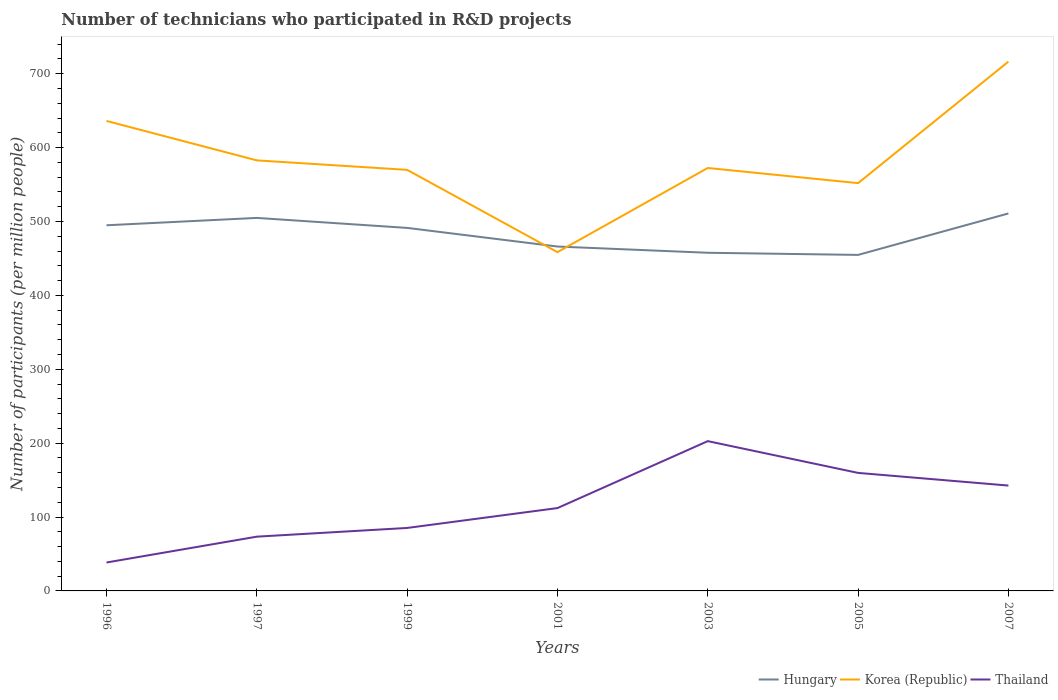Does the line corresponding to Thailand intersect with the line corresponding to Hungary?
Make the answer very short. No. Is the number of lines equal to the number of legend labels?
Offer a very short reply. Yes. Across all years, what is the maximum number of technicians who participated in R&D projects in Korea (Republic)?
Your response must be concise. 458.44. What is the total number of technicians who participated in R&D projects in Korea (Republic) in the graph?
Offer a very short reply. 17.98. What is the difference between the highest and the second highest number of technicians who participated in R&D projects in Thailand?
Your answer should be compact. 164.25. Does the graph contain any zero values?
Give a very brief answer. No. Where does the legend appear in the graph?
Provide a short and direct response. Bottom right. How many legend labels are there?
Ensure brevity in your answer.  3. How are the legend labels stacked?
Provide a succinct answer. Horizontal. What is the title of the graph?
Ensure brevity in your answer.  Number of technicians who participated in R&D projects. Does "Turkmenistan" appear as one of the legend labels in the graph?
Keep it short and to the point. No. What is the label or title of the Y-axis?
Make the answer very short. Number of participants (per million people). What is the Number of participants (per million people) of Hungary in 1996?
Give a very brief answer. 494.83. What is the Number of participants (per million people) of Korea (Republic) in 1996?
Provide a short and direct response. 636.02. What is the Number of participants (per million people) in Thailand in 1996?
Keep it short and to the point. 38.46. What is the Number of participants (per million people) in Hungary in 1997?
Your answer should be compact. 504.79. What is the Number of participants (per million people) of Korea (Republic) in 1997?
Provide a succinct answer. 582.66. What is the Number of participants (per million people) in Thailand in 1997?
Give a very brief answer. 73.43. What is the Number of participants (per million people) of Hungary in 1999?
Your answer should be very brief. 491.27. What is the Number of participants (per million people) of Korea (Republic) in 1999?
Your answer should be compact. 569.83. What is the Number of participants (per million people) of Thailand in 1999?
Make the answer very short. 85.21. What is the Number of participants (per million people) of Hungary in 2001?
Ensure brevity in your answer.  466.07. What is the Number of participants (per million people) of Korea (Republic) in 2001?
Ensure brevity in your answer.  458.44. What is the Number of participants (per million people) of Thailand in 2001?
Keep it short and to the point. 112.12. What is the Number of participants (per million people) of Hungary in 2003?
Your answer should be compact. 457.63. What is the Number of participants (per million people) of Korea (Republic) in 2003?
Your response must be concise. 572.37. What is the Number of participants (per million people) in Thailand in 2003?
Ensure brevity in your answer.  202.71. What is the Number of participants (per million people) in Hungary in 2005?
Ensure brevity in your answer.  454.74. What is the Number of participants (per million people) of Korea (Republic) in 2005?
Your response must be concise. 551.85. What is the Number of participants (per million people) in Thailand in 2005?
Ensure brevity in your answer.  159.72. What is the Number of participants (per million people) in Hungary in 2007?
Your response must be concise. 510.82. What is the Number of participants (per million people) in Korea (Republic) in 2007?
Keep it short and to the point. 716.3. What is the Number of participants (per million people) in Thailand in 2007?
Give a very brief answer. 142.58. Across all years, what is the maximum Number of participants (per million people) of Hungary?
Your answer should be compact. 510.82. Across all years, what is the maximum Number of participants (per million people) of Korea (Republic)?
Make the answer very short. 716.3. Across all years, what is the maximum Number of participants (per million people) of Thailand?
Ensure brevity in your answer.  202.71. Across all years, what is the minimum Number of participants (per million people) of Hungary?
Give a very brief answer. 454.74. Across all years, what is the minimum Number of participants (per million people) of Korea (Republic)?
Offer a terse response. 458.44. Across all years, what is the minimum Number of participants (per million people) of Thailand?
Offer a terse response. 38.46. What is the total Number of participants (per million people) in Hungary in the graph?
Offer a terse response. 3380.14. What is the total Number of participants (per million people) in Korea (Republic) in the graph?
Offer a very short reply. 4087.47. What is the total Number of participants (per million people) in Thailand in the graph?
Keep it short and to the point. 814.24. What is the difference between the Number of participants (per million people) of Hungary in 1996 and that in 1997?
Make the answer very short. -9.96. What is the difference between the Number of participants (per million people) of Korea (Republic) in 1996 and that in 1997?
Offer a very short reply. 53.36. What is the difference between the Number of participants (per million people) in Thailand in 1996 and that in 1997?
Offer a terse response. -34.97. What is the difference between the Number of participants (per million people) of Hungary in 1996 and that in 1999?
Provide a short and direct response. 3.56. What is the difference between the Number of participants (per million people) in Korea (Republic) in 1996 and that in 1999?
Your answer should be very brief. 66.19. What is the difference between the Number of participants (per million people) of Thailand in 1996 and that in 1999?
Offer a terse response. -46.75. What is the difference between the Number of participants (per million people) of Hungary in 1996 and that in 2001?
Your answer should be very brief. 28.76. What is the difference between the Number of participants (per million people) in Korea (Republic) in 1996 and that in 2001?
Provide a short and direct response. 177.58. What is the difference between the Number of participants (per million people) in Thailand in 1996 and that in 2001?
Offer a terse response. -73.66. What is the difference between the Number of participants (per million people) of Hungary in 1996 and that in 2003?
Provide a short and direct response. 37.2. What is the difference between the Number of participants (per million people) in Korea (Republic) in 1996 and that in 2003?
Your answer should be very brief. 63.65. What is the difference between the Number of participants (per million people) in Thailand in 1996 and that in 2003?
Offer a terse response. -164.25. What is the difference between the Number of participants (per million people) in Hungary in 1996 and that in 2005?
Your answer should be compact. 40.09. What is the difference between the Number of participants (per million people) in Korea (Republic) in 1996 and that in 2005?
Keep it short and to the point. 84.16. What is the difference between the Number of participants (per million people) in Thailand in 1996 and that in 2005?
Offer a very short reply. -121.26. What is the difference between the Number of participants (per million people) of Hungary in 1996 and that in 2007?
Your response must be concise. -15.99. What is the difference between the Number of participants (per million people) in Korea (Republic) in 1996 and that in 2007?
Ensure brevity in your answer.  -80.28. What is the difference between the Number of participants (per million people) of Thailand in 1996 and that in 2007?
Provide a short and direct response. -104.12. What is the difference between the Number of participants (per million people) of Hungary in 1997 and that in 1999?
Your response must be concise. 13.52. What is the difference between the Number of participants (per million people) in Korea (Republic) in 1997 and that in 1999?
Your response must be concise. 12.83. What is the difference between the Number of participants (per million people) in Thailand in 1997 and that in 1999?
Your answer should be compact. -11.78. What is the difference between the Number of participants (per million people) of Hungary in 1997 and that in 2001?
Keep it short and to the point. 38.72. What is the difference between the Number of participants (per million people) of Korea (Republic) in 1997 and that in 2001?
Provide a succinct answer. 124.22. What is the difference between the Number of participants (per million people) of Thailand in 1997 and that in 2001?
Ensure brevity in your answer.  -38.69. What is the difference between the Number of participants (per million people) in Hungary in 1997 and that in 2003?
Your answer should be compact. 47.16. What is the difference between the Number of participants (per million people) of Korea (Republic) in 1997 and that in 2003?
Your response must be concise. 10.29. What is the difference between the Number of participants (per million people) in Thailand in 1997 and that in 2003?
Give a very brief answer. -129.28. What is the difference between the Number of participants (per million people) in Hungary in 1997 and that in 2005?
Make the answer very short. 50.05. What is the difference between the Number of participants (per million people) in Korea (Republic) in 1997 and that in 2005?
Ensure brevity in your answer.  30.8. What is the difference between the Number of participants (per million people) in Thailand in 1997 and that in 2005?
Provide a short and direct response. -86.29. What is the difference between the Number of participants (per million people) in Hungary in 1997 and that in 2007?
Your answer should be compact. -6.03. What is the difference between the Number of participants (per million people) in Korea (Republic) in 1997 and that in 2007?
Your response must be concise. -133.64. What is the difference between the Number of participants (per million people) in Thailand in 1997 and that in 2007?
Provide a succinct answer. -69.15. What is the difference between the Number of participants (per million people) in Hungary in 1999 and that in 2001?
Provide a succinct answer. 25.2. What is the difference between the Number of participants (per million people) of Korea (Republic) in 1999 and that in 2001?
Offer a terse response. 111.39. What is the difference between the Number of participants (per million people) of Thailand in 1999 and that in 2001?
Your response must be concise. -26.91. What is the difference between the Number of participants (per million people) in Hungary in 1999 and that in 2003?
Your response must be concise. 33.64. What is the difference between the Number of participants (per million people) in Korea (Republic) in 1999 and that in 2003?
Provide a succinct answer. -2.54. What is the difference between the Number of participants (per million people) of Thailand in 1999 and that in 2003?
Offer a very short reply. -117.5. What is the difference between the Number of participants (per million people) in Hungary in 1999 and that in 2005?
Offer a terse response. 36.53. What is the difference between the Number of participants (per million people) of Korea (Republic) in 1999 and that in 2005?
Your answer should be very brief. 17.98. What is the difference between the Number of participants (per million people) in Thailand in 1999 and that in 2005?
Give a very brief answer. -74.51. What is the difference between the Number of participants (per million people) in Hungary in 1999 and that in 2007?
Your answer should be very brief. -19.56. What is the difference between the Number of participants (per million people) of Korea (Republic) in 1999 and that in 2007?
Make the answer very short. -146.47. What is the difference between the Number of participants (per million people) of Thailand in 1999 and that in 2007?
Provide a succinct answer. -57.37. What is the difference between the Number of participants (per million people) in Hungary in 2001 and that in 2003?
Offer a terse response. 8.44. What is the difference between the Number of participants (per million people) in Korea (Republic) in 2001 and that in 2003?
Your response must be concise. -113.93. What is the difference between the Number of participants (per million people) of Thailand in 2001 and that in 2003?
Ensure brevity in your answer.  -90.59. What is the difference between the Number of participants (per million people) of Hungary in 2001 and that in 2005?
Ensure brevity in your answer.  11.33. What is the difference between the Number of participants (per million people) of Korea (Republic) in 2001 and that in 2005?
Give a very brief answer. -93.41. What is the difference between the Number of participants (per million people) in Thailand in 2001 and that in 2005?
Your answer should be compact. -47.6. What is the difference between the Number of participants (per million people) in Hungary in 2001 and that in 2007?
Your answer should be very brief. -44.76. What is the difference between the Number of participants (per million people) in Korea (Republic) in 2001 and that in 2007?
Make the answer very short. -257.86. What is the difference between the Number of participants (per million people) in Thailand in 2001 and that in 2007?
Make the answer very short. -30.47. What is the difference between the Number of participants (per million people) of Hungary in 2003 and that in 2005?
Make the answer very short. 2.89. What is the difference between the Number of participants (per million people) of Korea (Republic) in 2003 and that in 2005?
Offer a very short reply. 20.51. What is the difference between the Number of participants (per million people) in Thailand in 2003 and that in 2005?
Provide a short and direct response. 42.99. What is the difference between the Number of participants (per million people) in Hungary in 2003 and that in 2007?
Provide a succinct answer. -53.2. What is the difference between the Number of participants (per million people) of Korea (Republic) in 2003 and that in 2007?
Give a very brief answer. -143.93. What is the difference between the Number of participants (per million people) in Thailand in 2003 and that in 2007?
Your answer should be very brief. 60.12. What is the difference between the Number of participants (per million people) of Hungary in 2005 and that in 2007?
Provide a short and direct response. -56.09. What is the difference between the Number of participants (per million people) in Korea (Republic) in 2005 and that in 2007?
Give a very brief answer. -164.45. What is the difference between the Number of participants (per million people) in Thailand in 2005 and that in 2007?
Ensure brevity in your answer.  17.14. What is the difference between the Number of participants (per million people) of Hungary in 1996 and the Number of participants (per million people) of Korea (Republic) in 1997?
Offer a very short reply. -87.83. What is the difference between the Number of participants (per million people) in Hungary in 1996 and the Number of participants (per million people) in Thailand in 1997?
Your answer should be very brief. 421.4. What is the difference between the Number of participants (per million people) in Korea (Republic) in 1996 and the Number of participants (per million people) in Thailand in 1997?
Your response must be concise. 562.58. What is the difference between the Number of participants (per million people) of Hungary in 1996 and the Number of participants (per million people) of Korea (Republic) in 1999?
Ensure brevity in your answer.  -75. What is the difference between the Number of participants (per million people) in Hungary in 1996 and the Number of participants (per million people) in Thailand in 1999?
Make the answer very short. 409.62. What is the difference between the Number of participants (per million people) of Korea (Republic) in 1996 and the Number of participants (per million people) of Thailand in 1999?
Ensure brevity in your answer.  550.8. What is the difference between the Number of participants (per million people) of Hungary in 1996 and the Number of participants (per million people) of Korea (Republic) in 2001?
Keep it short and to the point. 36.39. What is the difference between the Number of participants (per million people) of Hungary in 1996 and the Number of participants (per million people) of Thailand in 2001?
Your answer should be compact. 382.71. What is the difference between the Number of participants (per million people) in Korea (Republic) in 1996 and the Number of participants (per million people) in Thailand in 2001?
Your response must be concise. 523.9. What is the difference between the Number of participants (per million people) of Hungary in 1996 and the Number of participants (per million people) of Korea (Republic) in 2003?
Your answer should be compact. -77.54. What is the difference between the Number of participants (per million people) in Hungary in 1996 and the Number of participants (per million people) in Thailand in 2003?
Your answer should be very brief. 292.12. What is the difference between the Number of participants (per million people) of Korea (Republic) in 1996 and the Number of participants (per million people) of Thailand in 2003?
Your answer should be very brief. 433.31. What is the difference between the Number of participants (per million people) of Hungary in 1996 and the Number of participants (per million people) of Korea (Republic) in 2005?
Your response must be concise. -57.03. What is the difference between the Number of participants (per million people) of Hungary in 1996 and the Number of participants (per million people) of Thailand in 2005?
Make the answer very short. 335.11. What is the difference between the Number of participants (per million people) in Korea (Republic) in 1996 and the Number of participants (per million people) in Thailand in 2005?
Your answer should be compact. 476.29. What is the difference between the Number of participants (per million people) in Hungary in 1996 and the Number of participants (per million people) in Korea (Republic) in 2007?
Offer a very short reply. -221.47. What is the difference between the Number of participants (per million people) in Hungary in 1996 and the Number of participants (per million people) in Thailand in 2007?
Offer a terse response. 352.24. What is the difference between the Number of participants (per million people) of Korea (Republic) in 1996 and the Number of participants (per million people) of Thailand in 2007?
Your answer should be compact. 493.43. What is the difference between the Number of participants (per million people) in Hungary in 1997 and the Number of participants (per million people) in Korea (Republic) in 1999?
Offer a terse response. -65.04. What is the difference between the Number of participants (per million people) of Hungary in 1997 and the Number of participants (per million people) of Thailand in 1999?
Offer a very short reply. 419.58. What is the difference between the Number of participants (per million people) in Korea (Republic) in 1997 and the Number of participants (per million people) in Thailand in 1999?
Give a very brief answer. 497.44. What is the difference between the Number of participants (per million people) of Hungary in 1997 and the Number of participants (per million people) of Korea (Republic) in 2001?
Ensure brevity in your answer.  46.35. What is the difference between the Number of participants (per million people) of Hungary in 1997 and the Number of participants (per million people) of Thailand in 2001?
Make the answer very short. 392.67. What is the difference between the Number of participants (per million people) in Korea (Republic) in 1997 and the Number of participants (per million people) in Thailand in 2001?
Your response must be concise. 470.54. What is the difference between the Number of participants (per million people) in Hungary in 1997 and the Number of participants (per million people) in Korea (Republic) in 2003?
Your response must be concise. -67.58. What is the difference between the Number of participants (per million people) of Hungary in 1997 and the Number of participants (per million people) of Thailand in 2003?
Provide a succinct answer. 302.08. What is the difference between the Number of participants (per million people) of Korea (Republic) in 1997 and the Number of participants (per million people) of Thailand in 2003?
Provide a short and direct response. 379.95. What is the difference between the Number of participants (per million people) in Hungary in 1997 and the Number of participants (per million people) in Korea (Republic) in 2005?
Keep it short and to the point. -47.06. What is the difference between the Number of participants (per million people) of Hungary in 1997 and the Number of participants (per million people) of Thailand in 2005?
Provide a succinct answer. 345.07. What is the difference between the Number of participants (per million people) in Korea (Republic) in 1997 and the Number of participants (per million people) in Thailand in 2005?
Give a very brief answer. 422.93. What is the difference between the Number of participants (per million people) of Hungary in 1997 and the Number of participants (per million people) of Korea (Republic) in 2007?
Offer a terse response. -211.51. What is the difference between the Number of participants (per million people) of Hungary in 1997 and the Number of participants (per million people) of Thailand in 2007?
Make the answer very short. 362.2. What is the difference between the Number of participants (per million people) of Korea (Republic) in 1997 and the Number of participants (per million people) of Thailand in 2007?
Offer a very short reply. 440.07. What is the difference between the Number of participants (per million people) in Hungary in 1999 and the Number of participants (per million people) in Korea (Republic) in 2001?
Give a very brief answer. 32.82. What is the difference between the Number of participants (per million people) of Hungary in 1999 and the Number of participants (per million people) of Thailand in 2001?
Offer a very short reply. 379.15. What is the difference between the Number of participants (per million people) of Korea (Republic) in 1999 and the Number of participants (per million people) of Thailand in 2001?
Offer a terse response. 457.71. What is the difference between the Number of participants (per million people) of Hungary in 1999 and the Number of participants (per million people) of Korea (Republic) in 2003?
Make the answer very short. -81.1. What is the difference between the Number of participants (per million people) of Hungary in 1999 and the Number of participants (per million people) of Thailand in 2003?
Your response must be concise. 288.56. What is the difference between the Number of participants (per million people) in Korea (Republic) in 1999 and the Number of participants (per million people) in Thailand in 2003?
Give a very brief answer. 367.12. What is the difference between the Number of participants (per million people) in Hungary in 1999 and the Number of participants (per million people) in Korea (Republic) in 2005?
Make the answer very short. -60.59. What is the difference between the Number of participants (per million people) in Hungary in 1999 and the Number of participants (per million people) in Thailand in 2005?
Keep it short and to the point. 331.54. What is the difference between the Number of participants (per million people) of Korea (Republic) in 1999 and the Number of participants (per million people) of Thailand in 2005?
Offer a very short reply. 410.11. What is the difference between the Number of participants (per million people) of Hungary in 1999 and the Number of participants (per million people) of Korea (Republic) in 2007?
Offer a very short reply. -225.03. What is the difference between the Number of participants (per million people) in Hungary in 1999 and the Number of participants (per million people) in Thailand in 2007?
Your answer should be very brief. 348.68. What is the difference between the Number of participants (per million people) in Korea (Republic) in 1999 and the Number of participants (per million people) in Thailand in 2007?
Provide a succinct answer. 427.25. What is the difference between the Number of participants (per million people) in Hungary in 2001 and the Number of participants (per million people) in Korea (Republic) in 2003?
Provide a short and direct response. -106.3. What is the difference between the Number of participants (per million people) in Hungary in 2001 and the Number of participants (per million people) in Thailand in 2003?
Provide a succinct answer. 263.36. What is the difference between the Number of participants (per million people) of Korea (Republic) in 2001 and the Number of participants (per million people) of Thailand in 2003?
Make the answer very short. 255.73. What is the difference between the Number of participants (per million people) in Hungary in 2001 and the Number of participants (per million people) in Korea (Republic) in 2005?
Offer a very short reply. -85.79. What is the difference between the Number of participants (per million people) in Hungary in 2001 and the Number of participants (per million people) in Thailand in 2005?
Your answer should be very brief. 306.34. What is the difference between the Number of participants (per million people) in Korea (Republic) in 2001 and the Number of participants (per million people) in Thailand in 2005?
Give a very brief answer. 298.72. What is the difference between the Number of participants (per million people) in Hungary in 2001 and the Number of participants (per million people) in Korea (Republic) in 2007?
Make the answer very short. -250.23. What is the difference between the Number of participants (per million people) in Hungary in 2001 and the Number of participants (per million people) in Thailand in 2007?
Provide a succinct answer. 323.48. What is the difference between the Number of participants (per million people) of Korea (Republic) in 2001 and the Number of participants (per million people) of Thailand in 2007?
Make the answer very short. 315.86. What is the difference between the Number of participants (per million people) of Hungary in 2003 and the Number of participants (per million people) of Korea (Republic) in 2005?
Your answer should be very brief. -94.23. What is the difference between the Number of participants (per million people) of Hungary in 2003 and the Number of participants (per million people) of Thailand in 2005?
Make the answer very short. 297.9. What is the difference between the Number of participants (per million people) of Korea (Republic) in 2003 and the Number of participants (per million people) of Thailand in 2005?
Keep it short and to the point. 412.64. What is the difference between the Number of participants (per million people) of Hungary in 2003 and the Number of participants (per million people) of Korea (Republic) in 2007?
Offer a very short reply. -258.67. What is the difference between the Number of participants (per million people) in Hungary in 2003 and the Number of participants (per million people) in Thailand in 2007?
Your answer should be compact. 315.04. What is the difference between the Number of participants (per million people) of Korea (Republic) in 2003 and the Number of participants (per million people) of Thailand in 2007?
Keep it short and to the point. 429.78. What is the difference between the Number of participants (per million people) in Hungary in 2005 and the Number of participants (per million people) in Korea (Republic) in 2007?
Offer a very short reply. -261.56. What is the difference between the Number of participants (per million people) in Hungary in 2005 and the Number of participants (per million people) in Thailand in 2007?
Keep it short and to the point. 312.15. What is the difference between the Number of participants (per million people) in Korea (Republic) in 2005 and the Number of participants (per million people) in Thailand in 2007?
Make the answer very short. 409.27. What is the average Number of participants (per million people) in Hungary per year?
Offer a very short reply. 482.88. What is the average Number of participants (per million people) of Korea (Republic) per year?
Ensure brevity in your answer.  583.92. What is the average Number of participants (per million people) of Thailand per year?
Ensure brevity in your answer.  116.32. In the year 1996, what is the difference between the Number of participants (per million people) of Hungary and Number of participants (per million people) of Korea (Republic)?
Make the answer very short. -141.19. In the year 1996, what is the difference between the Number of participants (per million people) of Hungary and Number of participants (per million people) of Thailand?
Keep it short and to the point. 456.37. In the year 1996, what is the difference between the Number of participants (per million people) in Korea (Republic) and Number of participants (per million people) in Thailand?
Provide a succinct answer. 597.56. In the year 1997, what is the difference between the Number of participants (per million people) in Hungary and Number of participants (per million people) in Korea (Republic)?
Provide a succinct answer. -77.87. In the year 1997, what is the difference between the Number of participants (per million people) of Hungary and Number of participants (per million people) of Thailand?
Your answer should be very brief. 431.36. In the year 1997, what is the difference between the Number of participants (per million people) of Korea (Republic) and Number of participants (per million people) of Thailand?
Your answer should be very brief. 509.22. In the year 1999, what is the difference between the Number of participants (per million people) in Hungary and Number of participants (per million people) in Korea (Republic)?
Ensure brevity in your answer.  -78.57. In the year 1999, what is the difference between the Number of participants (per million people) of Hungary and Number of participants (per million people) of Thailand?
Provide a succinct answer. 406.05. In the year 1999, what is the difference between the Number of participants (per million people) in Korea (Republic) and Number of participants (per million people) in Thailand?
Give a very brief answer. 484.62. In the year 2001, what is the difference between the Number of participants (per million people) of Hungary and Number of participants (per million people) of Korea (Republic)?
Provide a short and direct response. 7.62. In the year 2001, what is the difference between the Number of participants (per million people) in Hungary and Number of participants (per million people) in Thailand?
Your answer should be very brief. 353.95. In the year 2001, what is the difference between the Number of participants (per million people) of Korea (Republic) and Number of participants (per million people) of Thailand?
Your answer should be very brief. 346.32. In the year 2003, what is the difference between the Number of participants (per million people) in Hungary and Number of participants (per million people) in Korea (Republic)?
Keep it short and to the point. -114.74. In the year 2003, what is the difference between the Number of participants (per million people) of Hungary and Number of participants (per million people) of Thailand?
Ensure brevity in your answer.  254.92. In the year 2003, what is the difference between the Number of participants (per million people) of Korea (Republic) and Number of participants (per million people) of Thailand?
Keep it short and to the point. 369.66. In the year 2005, what is the difference between the Number of participants (per million people) of Hungary and Number of participants (per million people) of Korea (Republic)?
Your response must be concise. -97.12. In the year 2005, what is the difference between the Number of participants (per million people) of Hungary and Number of participants (per million people) of Thailand?
Ensure brevity in your answer.  295.01. In the year 2005, what is the difference between the Number of participants (per million people) of Korea (Republic) and Number of participants (per million people) of Thailand?
Your answer should be very brief. 392.13. In the year 2007, what is the difference between the Number of participants (per million people) in Hungary and Number of participants (per million people) in Korea (Republic)?
Give a very brief answer. -205.48. In the year 2007, what is the difference between the Number of participants (per million people) of Hungary and Number of participants (per million people) of Thailand?
Keep it short and to the point. 368.24. In the year 2007, what is the difference between the Number of participants (per million people) in Korea (Republic) and Number of participants (per million people) in Thailand?
Give a very brief answer. 573.72. What is the ratio of the Number of participants (per million people) of Hungary in 1996 to that in 1997?
Provide a short and direct response. 0.98. What is the ratio of the Number of participants (per million people) in Korea (Republic) in 1996 to that in 1997?
Make the answer very short. 1.09. What is the ratio of the Number of participants (per million people) in Thailand in 1996 to that in 1997?
Provide a short and direct response. 0.52. What is the ratio of the Number of participants (per million people) of Hungary in 1996 to that in 1999?
Provide a succinct answer. 1.01. What is the ratio of the Number of participants (per million people) in Korea (Republic) in 1996 to that in 1999?
Offer a very short reply. 1.12. What is the ratio of the Number of participants (per million people) of Thailand in 1996 to that in 1999?
Your answer should be very brief. 0.45. What is the ratio of the Number of participants (per million people) in Hungary in 1996 to that in 2001?
Offer a very short reply. 1.06. What is the ratio of the Number of participants (per million people) in Korea (Republic) in 1996 to that in 2001?
Provide a short and direct response. 1.39. What is the ratio of the Number of participants (per million people) in Thailand in 1996 to that in 2001?
Your answer should be compact. 0.34. What is the ratio of the Number of participants (per million people) of Hungary in 1996 to that in 2003?
Offer a very short reply. 1.08. What is the ratio of the Number of participants (per million people) in Korea (Republic) in 1996 to that in 2003?
Keep it short and to the point. 1.11. What is the ratio of the Number of participants (per million people) in Thailand in 1996 to that in 2003?
Your answer should be compact. 0.19. What is the ratio of the Number of participants (per million people) in Hungary in 1996 to that in 2005?
Keep it short and to the point. 1.09. What is the ratio of the Number of participants (per million people) in Korea (Republic) in 1996 to that in 2005?
Make the answer very short. 1.15. What is the ratio of the Number of participants (per million people) of Thailand in 1996 to that in 2005?
Your answer should be very brief. 0.24. What is the ratio of the Number of participants (per million people) of Hungary in 1996 to that in 2007?
Your answer should be compact. 0.97. What is the ratio of the Number of participants (per million people) of Korea (Republic) in 1996 to that in 2007?
Keep it short and to the point. 0.89. What is the ratio of the Number of participants (per million people) of Thailand in 1996 to that in 2007?
Ensure brevity in your answer.  0.27. What is the ratio of the Number of participants (per million people) in Hungary in 1997 to that in 1999?
Make the answer very short. 1.03. What is the ratio of the Number of participants (per million people) in Korea (Republic) in 1997 to that in 1999?
Your answer should be compact. 1.02. What is the ratio of the Number of participants (per million people) of Thailand in 1997 to that in 1999?
Your response must be concise. 0.86. What is the ratio of the Number of participants (per million people) in Hungary in 1997 to that in 2001?
Your answer should be very brief. 1.08. What is the ratio of the Number of participants (per million people) in Korea (Republic) in 1997 to that in 2001?
Ensure brevity in your answer.  1.27. What is the ratio of the Number of participants (per million people) in Thailand in 1997 to that in 2001?
Offer a terse response. 0.66. What is the ratio of the Number of participants (per million people) of Hungary in 1997 to that in 2003?
Ensure brevity in your answer.  1.1. What is the ratio of the Number of participants (per million people) in Thailand in 1997 to that in 2003?
Offer a very short reply. 0.36. What is the ratio of the Number of participants (per million people) of Hungary in 1997 to that in 2005?
Make the answer very short. 1.11. What is the ratio of the Number of participants (per million people) in Korea (Republic) in 1997 to that in 2005?
Offer a terse response. 1.06. What is the ratio of the Number of participants (per million people) in Thailand in 1997 to that in 2005?
Offer a very short reply. 0.46. What is the ratio of the Number of participants (per million people) in Korea (Republic) in 1997 to that in 2007?
Ensure brevity in your answer.  0.81. What is the ratio of the Number of participants (per million people) in Thailand in 1997 to that in 2007?
Make the answer very short. 0.52. What is the ratio of the Number of participants (per million people) in Hungary in 1999 to that in 2001?
Keep it short and to the point. 1.05. What is the ratio of the Number of participants (per million people) of Korea (Republic) in 1999 to that in 2001?
Provide a short and direct response. 1.24. What is the ratio of the Number of participants (per million people) in Thailand in 1999 to that in 2001?
Your answer should be very brief. 0.76. What is the ratio of the Number of participants (per million people) in Hungary in 1999 to that in 2003?
Ensure brevity in your answer.  1.07. What is the ratio of the Number of participants (per million people) of Thailand in 1999 to that in 2003?
Your answer should be compact. 0.42. What is the ratio of the Number of participants (per million people) in Hungary in 1999 to that in 2005?
Keep it short and to the point. 1.08. What is the ratio of the Number of participants (per million people) in Korea (Republic) in 1999 to that in 2005?
Provide a short and direct response. 1.03. What is the ratio of the Number of participants (per million people) in Thailand in 1999 to that in 2005?
Give a very brief answer. 0.53. What is the ratio of the Number of participants (per million people) of Hungary in 1999 to that in 2007?
Provide a succinct answer. 0.96. What is the ratio of the Number of participants (per million people) of Korea (Republic) in 1999 to that in 2007?
Provide a succinct answer. 0.8. What is the ratio of the Number of participants (per million people) of Thailand in 1999 to that in 2007?
Ensure brevity in your answer.  0.6. What is the ratio of the Number of participants (per million people) in Hungary in 2001 to that in 2003?
Keep it short and to the point. 1.02. What is the ratio of the Number of participants (per million people) of Korea (Republic) in 2001 to that in 2003?
Your answer should be very brief. 0.8. What is the ratio of the Number of participants (per million people) of Thailand in 2001 to that in 2003?
Keep it short and to the point. 0.55. What is the ratio of the Number of participants (per million people) of Hungary in 2001 to that in 2005?
Your response must be concise. 1.02. What is the ratio of the Number of participants (per million people) in Korea (Republic) in 2001 to that in 2005?
Your answer should be very brief. 0.83. What is the ratio of the Number of participants (per million people) of Thailand in 2001 to that in 2005?
Offer a terse response. 0.7. What is the ratio of the Number of participants (per million people) of Hungary in 2001 to that in 2007?
Make the answer very short. 0.91. What is the ratio of the Number of participants (per million people) of Korea (Republic) in 2001 to that in 2007?
Offer a very short reply. 0.64. What is the ratio of the Number of participants (per million people) of Thailand in 2001 to that in 2007?
Your answer should be very brief. 0.79. What is the ratio of the Number of participants (per million people) in Hungary in 2003 to that in 2005?
Give a very brief answer. 1.01. What is the ratio of the Number of participants (per million people) in Korea (Republic) in 2003 to that in 2005?
Make the answer very short. 1.04. What is the ratio of the Number of participants (per million people) in Thailand in 2003 to that in 2005?
Your answer should be compact. 1.27. What is the ratio of the Number of participants (per million people) of Hungary in 2003 to that in 2007?
Keep it short and to the point. 0.9. What is the ratio of the Number of participants (per million people) in Korea (Republic) in 2003 to that in 2007?
Your response must be concise. 0.8. What is the ratio of the Number of participants (per million people) of Thailand in 2003 to that in 2007?
Offer a very short reply. 1.42. What is the ratio of the Number of participants (per million people) in Hungary in 2005 to that in 2007?
Give a very brief answer. 0.89. What is the ratio of the Number of participants (per million people) of Korea (Republic) in 2005 to that in 2007?
Make the answer very short. 0.77. What is the ratio of the Number of participants (per million people) of Thailand in 2005 to that in 2007?
Provide a succinct answer. 1.12. What is the difference between the highest and the second highest Number of participants (per million people) of Hungary?
Your answer should be very brief. 6.03. What is the difference between the highest and the second highest Number of participants (per million people) in Korea (Republic)?
Offer a terse response. 80.28. What is the difference between the highest and the second highest Number of participants (per million people) of Thailand?
Your answer should be very brief. 42.99. What is the difference between the highest and the lowest Number of participants (per million people) of Hungary?
Make the answer very short. 56.09. What is the difference between the highest and the lowest Number of participants (per million people) in Korea (Republic)?
Offer a very short reply. 257.86. What is the difference between the highest and the lowest Number of participants (per million people) of Thailand?
Your answer should be very brief. 164.25. 